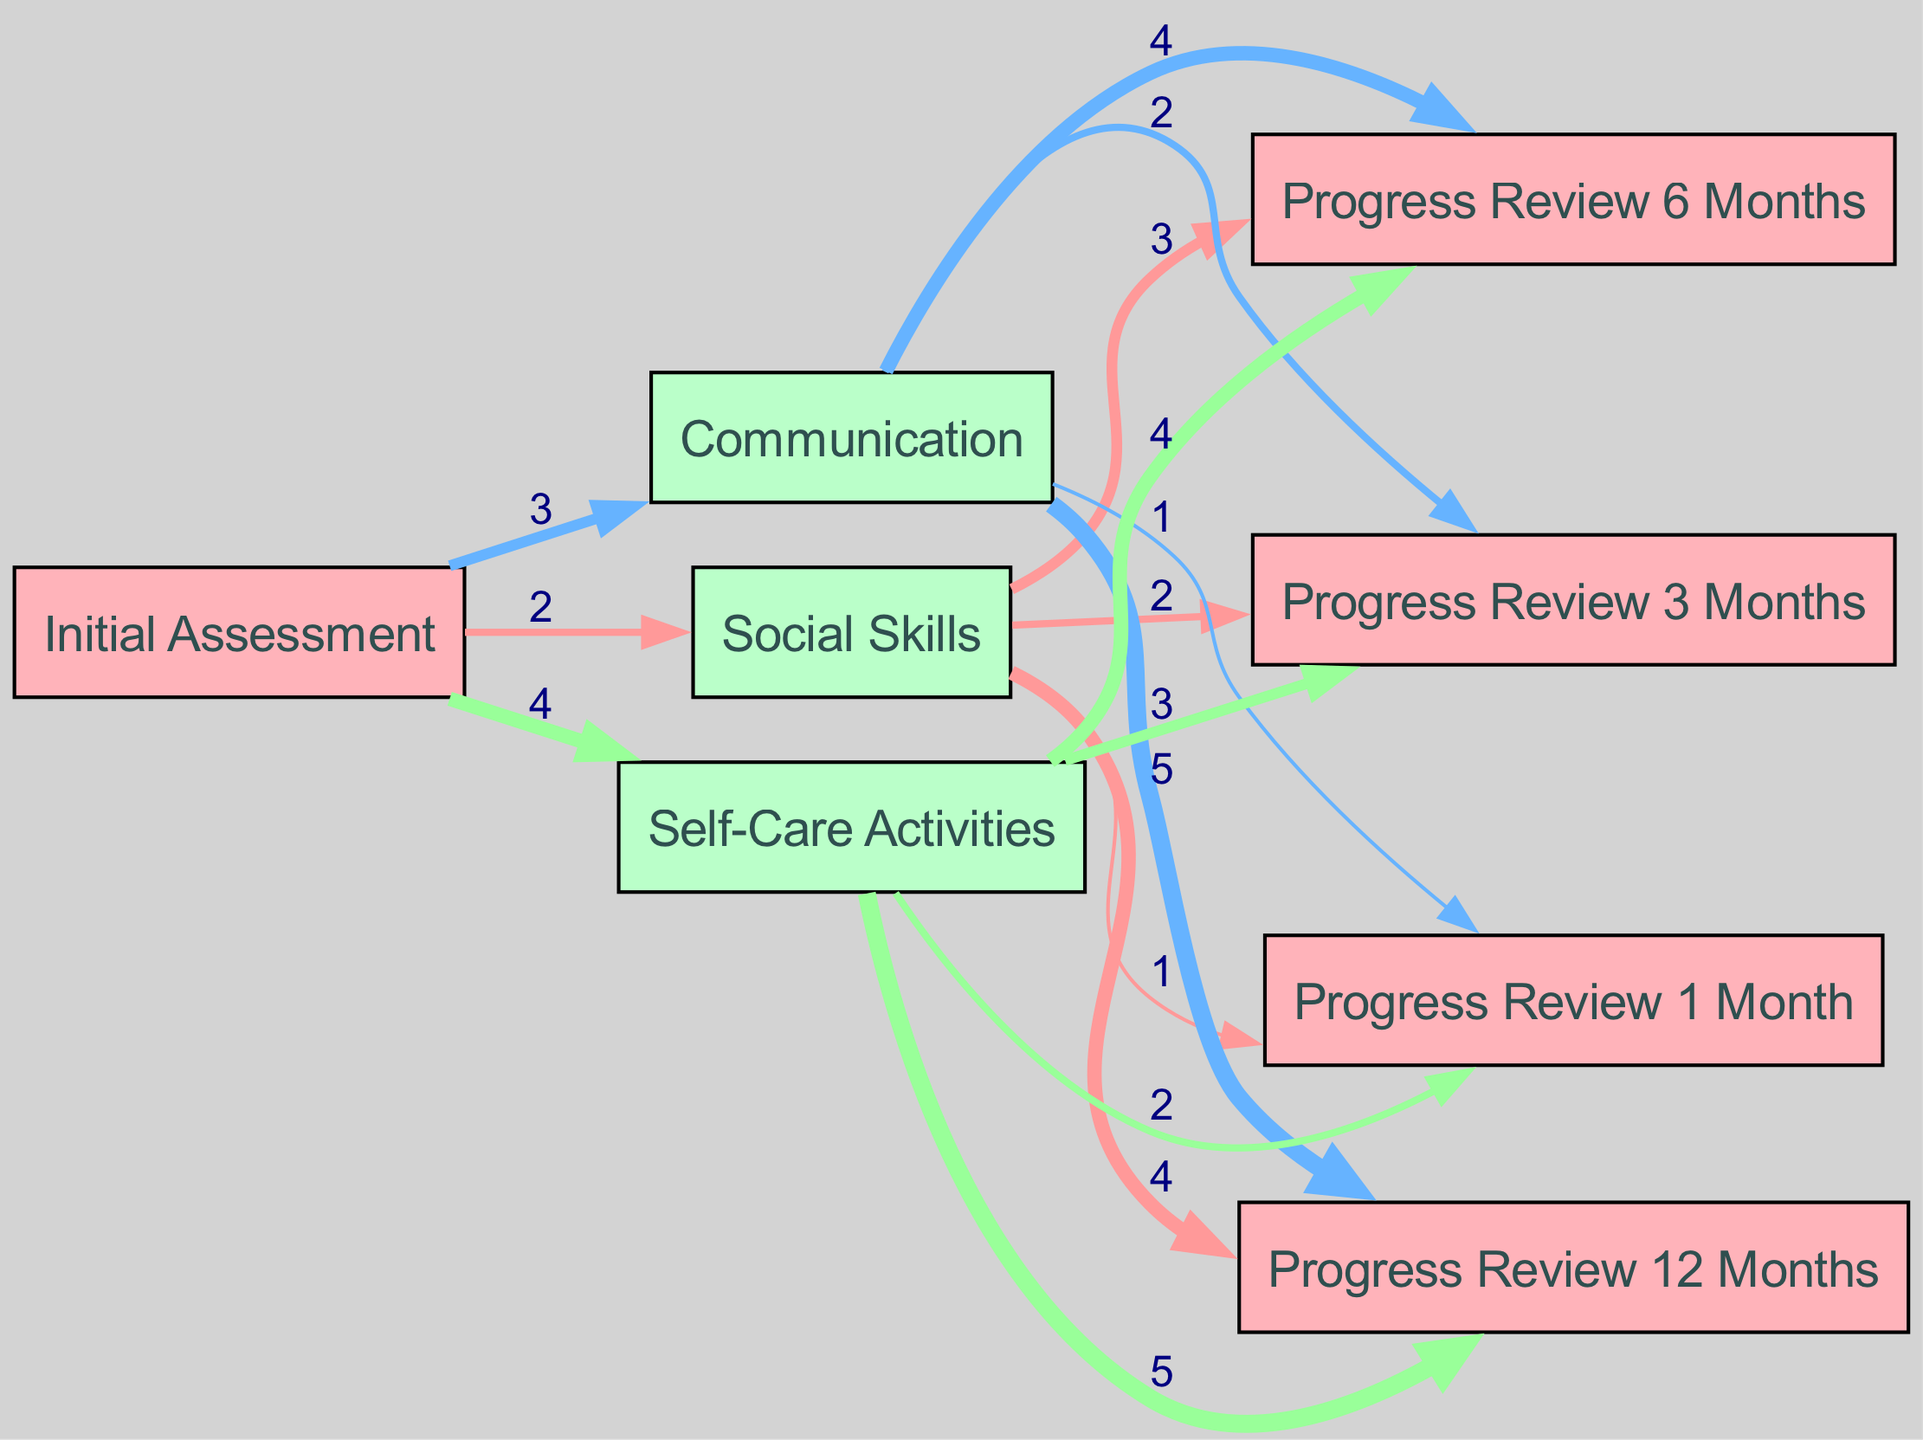What is the total number of skills assessed in the initial assessment? In the initial assessment, the skills assessed are Social Skills, Communication, and Self-Care Activities. Counting these, we find there are three skills.
Answer: 3 Which skill received the highest value at the initial assessment? From the initial assessment, Self-Care Activities received a value of 4, which is the highest compared to Social Skills (2) and Communication (3).
Answer: Self-Care Activities How many skills showed improvement after 12 months? At the 12-month review, all three skills (Social Skills, Communication, and Self-Care Activities) show improvement, indicated by the links connecting them to this stage. Counting these gives us three skills.
Answer: 3 What is the value assigned to the Social Skills at the 6-month review? The value assigned to Social Skills at the 6-month review is 3, as indicated by the link from Social Skills to Progress Review 6 Months.
Answer: 3 Which skill experienced the least improvement from the initial assessment to the 1-month review? Comparing the initial assessment and the 1-month review values, Social Skills showed an improvement from 2 to 1 (a decrease), which indicates the least improvement in this case.
Answer: Social Skills What is the total value for self-care activities after 3 months? The value for Self-Care Activities after 3 months is 3, as shown in the link connecting Self-Care Activities to Progress Review 3 Months. It increases from 4 in the initial assessment to 3 in the review.
Answer: 3 What is the overall trend of the communication skill from initial assessment to 12 months? The trend for communication skill shows a continuous increase: starting at 3 (initial assessment), then to 1 (1 month), 2 (3 months), 4 (6 months), and finally reaching 5 (12 months review). This indicates an upward trend throughout the year.
Answer: Upward trend How many total links are there in the diagram? Counting all the links connecting nodes, there are 15 links shown in the diagram, depicting the relationships between skills and reviews.
Answer: 15 Which skill had the highest value at the 12-month review? At the 12-month review, the skill with the highest value is Communication, which has a value of 5, more than any other skills at that stage.
Answer: Communication 